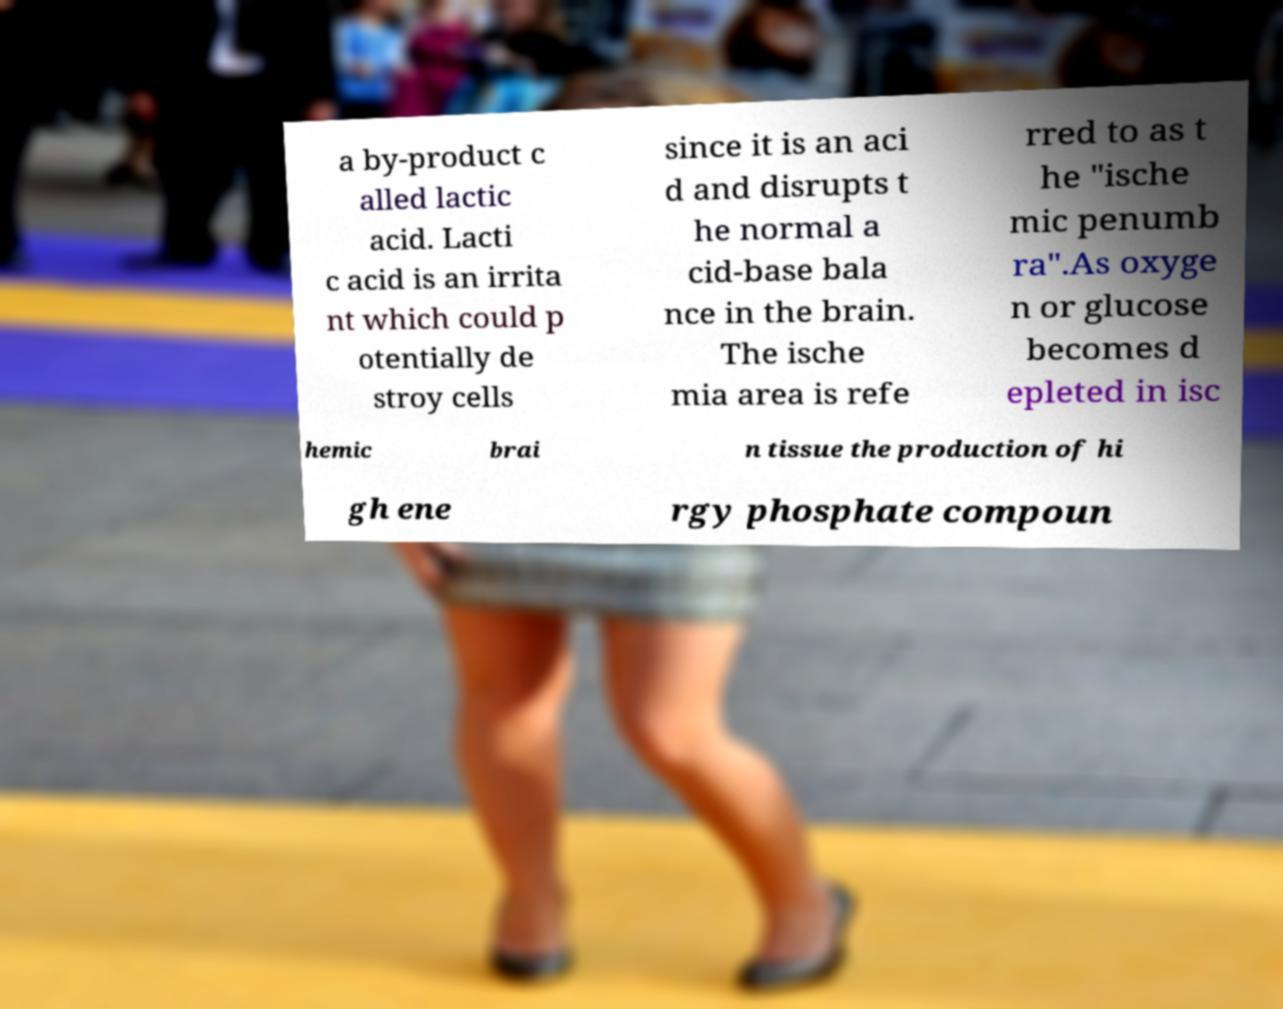There's text embedded in this image that I need extracted. Can you transcribe it verbatim? a by-product c alled lactic acid. Lacti c acid is an irrita nt which could p otentially de stroy cells since it is an aci d and disrupts t he normal a cid-base bala nce in the brain. The ische mia area is refe rred to as t he "ische mic penumb ra".As oxyge n or glucose becomes d epleted in isc hemic brai n tissue the production of hi gh ene rgy phosphate compoun 